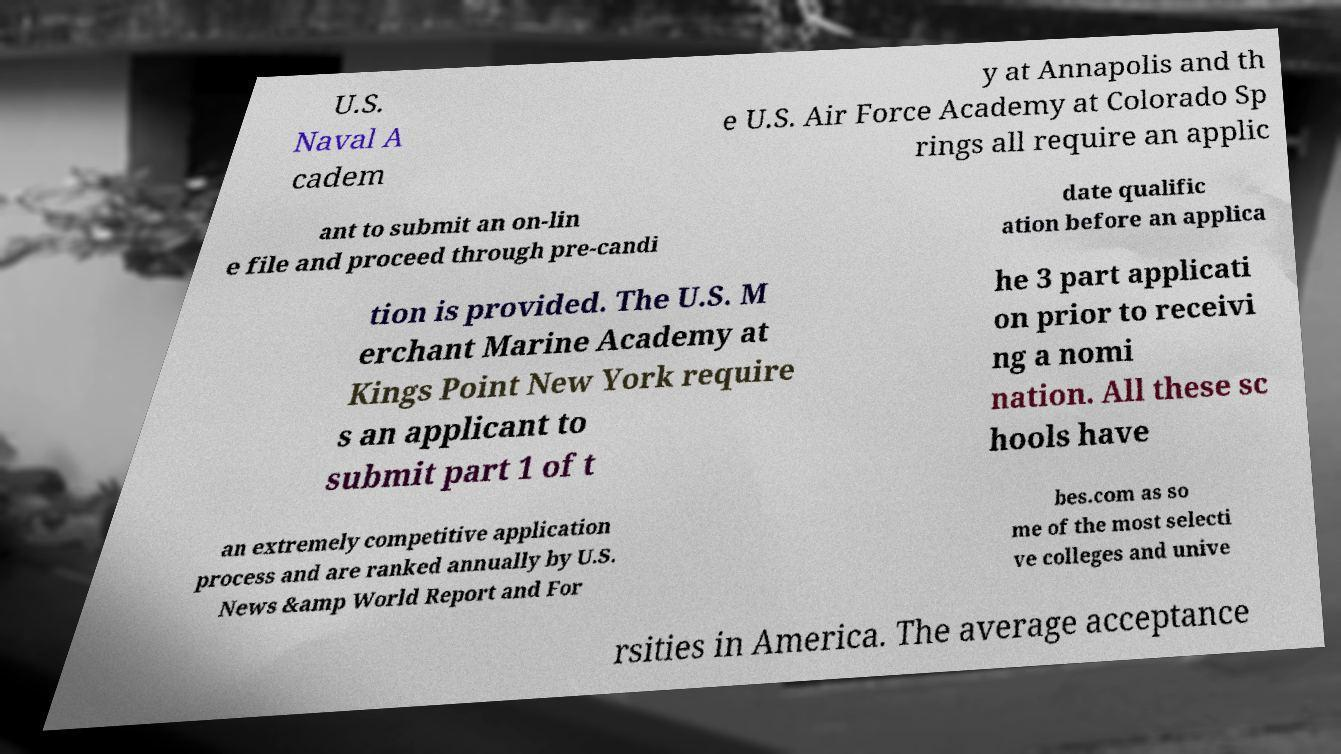Please identify and transcribe the text found in this image. U.S. Naval A cadem y at Annapolis and th e U.S. Air Force Academy at Colorado Sp rings all require an applic ant to submit an on-lin e file and proceed through pre-candi date qualific ation before an applica tion is provided. The U.S. M erchant Marine Academy at Kings Point New York require s an applicant to submit part 1 of t he 3 part applicati on prior to receivi ng a nomi nation. All these sc hools have an extremely competitive application process and are ranked annually by U.S. News &amp World Report and For bes.com as so me of the most selecti ve colleges and unive rsities in America. The average acceptance 